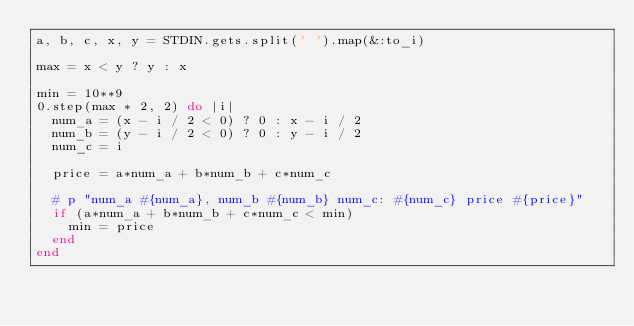<code> <loc_0><loc_0><loc_500><loc_500><_Ruby_>a, b, c, x, y = STDIN.gets.split(' ').map(&:to_i)

max = x < y ? y : x

min = 10**9
0.step(max * 2, 2) do |i|
  num_a = (x - i / 2 < 0) ? 0 : x - i / 2
  num_b = (y - i / 2 < 0) ? 0 : y - i / 2
  num_c = i
  
  price = a*num_a + b*num_b + c*num_c
  
  # p "num_a #{num_a}, num_b #{num_b} num_c: #{num_c} price #{price}"
  if (a*num_a + b*num_b + c*num_c < min)
    min = price
  end
end</code> 